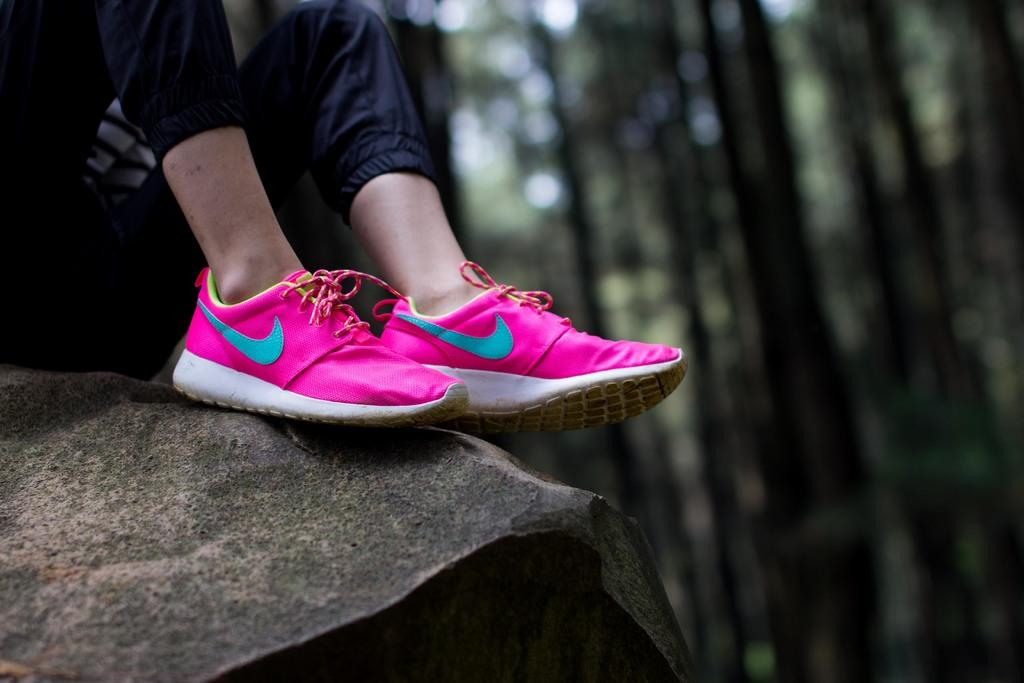Who or what is present in the image? There is a person in the image. What can be observed about the person's shoes? The person is wearing pink shoes. Where are the shoes placed? The shoes are placed on a rock. What can be seen in the background of the image? There are trees in the background of the image. What is the taste of the scarecrow in the image? There is no scarecrow present in the image, so it is not possible to determine its taste. 